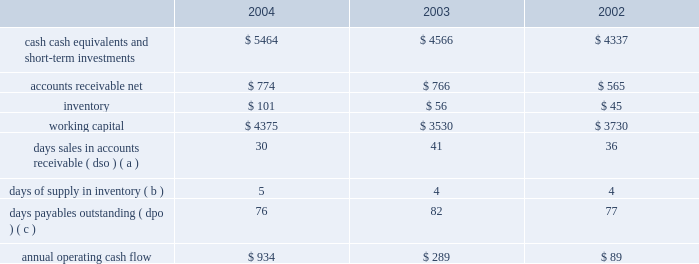Liquidity and capital resources the table presents selected financial information and statistics for each of the last three fiscal years ( dollars in millions ) : .
( a ) dso is based on ending net trade receivables and most recent quarterly net sales for each period .
( b ) days supply of inventory is based on ending inventory and most recent quarterly cost of sales for each period .
( c ) dpo is based on ending accounts payable and most recent quarterly cost of sales adjusted for the change in inventory .
As of september 25 , 2004 , the company had $ 5.464 billion in cash , cash equivalents , and short-term investments , an increase of $ 898 million over the same balances at the end of fiscal 2003 .
The principal components of this increase were cash generated by operating activities of $ 934 million and proceeds of $ 427 million from the issuance of common stock under stock plans , partially offset by cash used to repay the company 2019s outstanding debt of $ 300 million and purchases of property , plant , and equipment of $ 176 million .
The company 2019s short-term investment portfolio is primarily invested in high credit quality , liquid investments .
Approximately $ 3.2 billion of this cash , cash equivalents , and short-term investments are held by the company 2019s foreign subsidiaries and would be subject to u.s .
Income taxation on repatriation to the u.s .
The company is currently assessing the impact of the one-time favorable foreign dividend provisions recently enacted as part of the american jobs creation act of 2004 , and may decide to repatriate earnings from some of its foreign subsidiaries .
The company believes its existing balances of cash , cash equivalents , and short-term investments will be sufficient to satisfy its working capital needs , capital expenditures , stock repurchase activity , outstanding commitments , and other liquidity requirements associated with its existing operations over the next 12 months .
In february 2004 , the company retired $ 300 million of debt outstanding in the form of 6.5% ( 6.5 % ) unsecured notes .
The notes were originally issued in 1994 and were sold at 99.9925% ( 99.9925 % ) of par for an effective yield to maturity of 6.51% ( 6.51 % ) .
The company currently has no long-term debt obligations .
Capital expenditures the company 2019s total capital expenditures were $ 176 million during fiscal 2004 , $ 104 million of which were for retail store facilities and equipment related to the company 2019s retail segment and $ 72 million of which were primarily for corporate infrastructure , including information systems enhancements and operating facilities enhancements and expansions .
The company currently anticipates it will utilize approximately $ 240 million for capital expenditures during 2005 , approximately $ 125 million of which is expected to be utilized for further expansion of the company 2019s retail segment and the remainder utilized to support normal replacement of existing capital assets and enhancements to general information technology infrastructure. .
What was the lowest amount of accounts receivable net , in millions? 
Computations: table_min(accounts receivable net, none)
Answer: 565.0. 